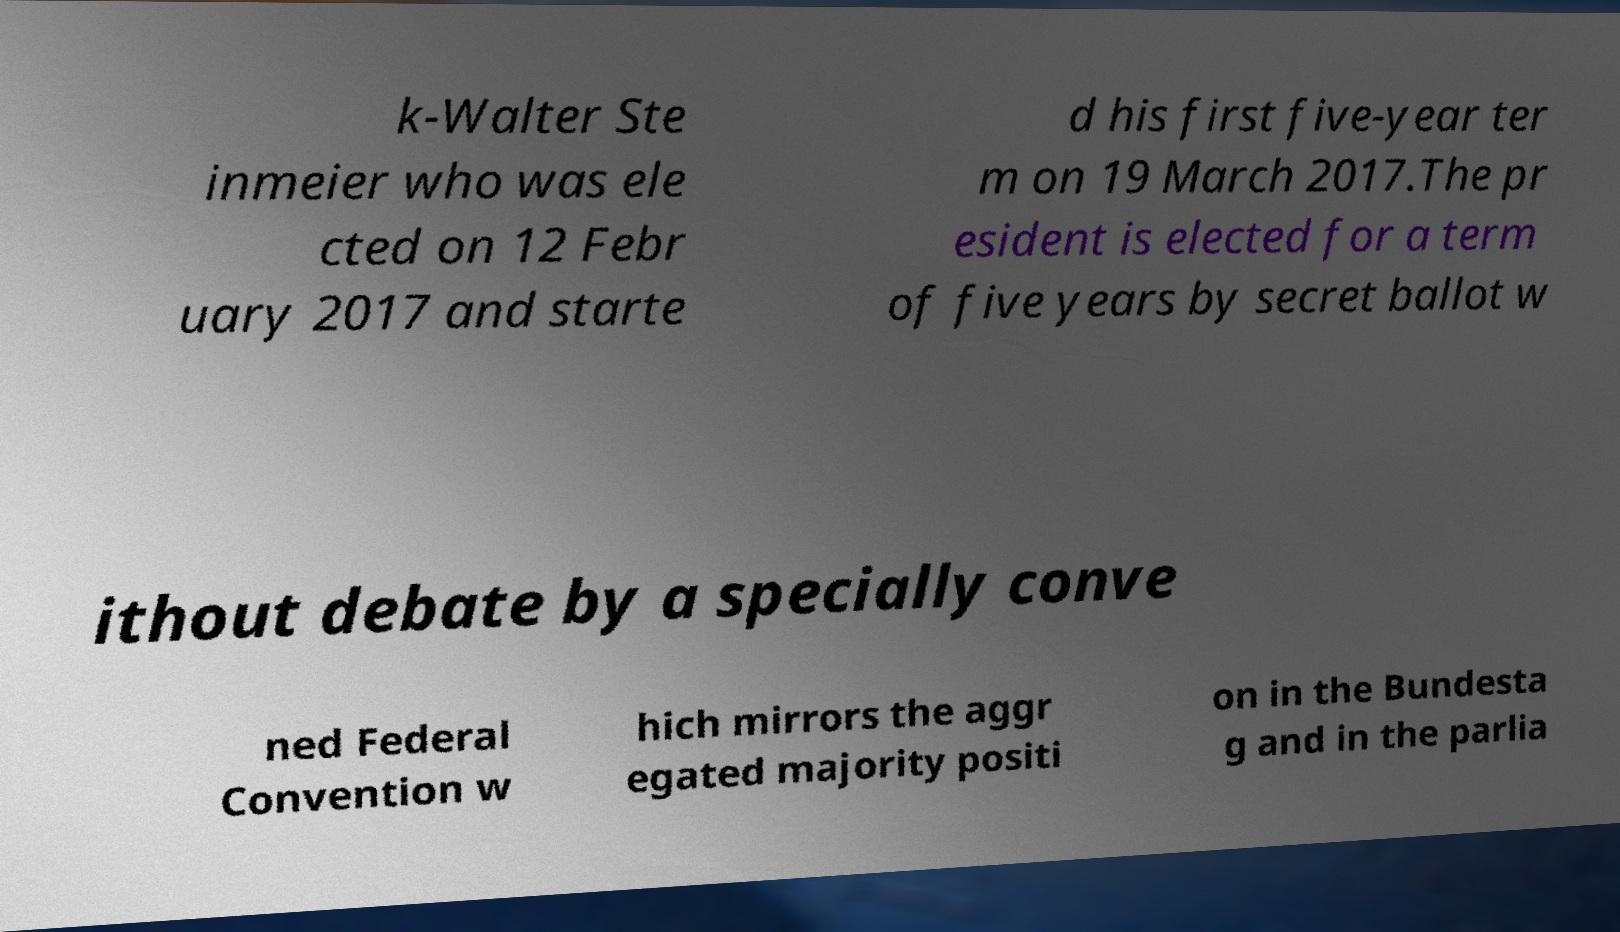What messages or text are displayed in this image? I need them in a readable, typed format. k-Walter Ste inmeier who was ele cted on 12 Febr uary 2017 and starte d his first five-year ter m on 19 March 2017.The pr esident is elected for a term of five years by secret ballot w ithout debate by a specially conve ned Federal Convention w hich mirrors the aggr egated majority positi on in the Bundesta g and in the parlia 